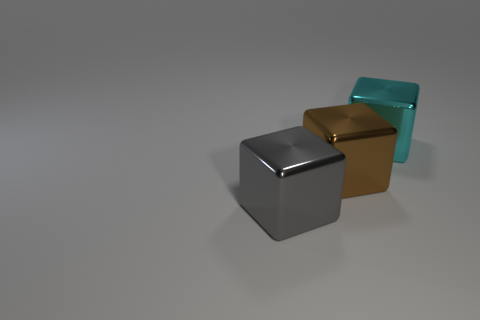How many other objects are the same material as the big brown cube?
Keep it short and to the point. 2. Is the material of the object that is on the right side of the brown block the same as the big block that is to the left of the brown thing?
Your response must be concise. Yes. There is a shiny thing to the left of the big brown thing; what size is it?
Offer a terse response. Large. What is the material of the big cyan object that is the same shape as the brown object?
Ensure brevity in your answer.  Metal. The shiny thing that is on the left side of the brown block has what shape?
Offer a very short reply. Cube. How many other large objects have the same shape as the cyan metal thing?
Provide a short and direct response. 2. Are there an equal number of shiny things right of the big brown object and big brown shiny objects right of the large cyan metal thing?
Your response must be concise. No. Are there any other objects made of the same material as the brown thing?
Keep it short and to the point. Yes. What number of purple things are either large objects or large cylinders?
Give a very brief answer. 0. Are there more large cyan blocks behind the big brown shiny block than gray shiny things?
Offer a terse response. No. 